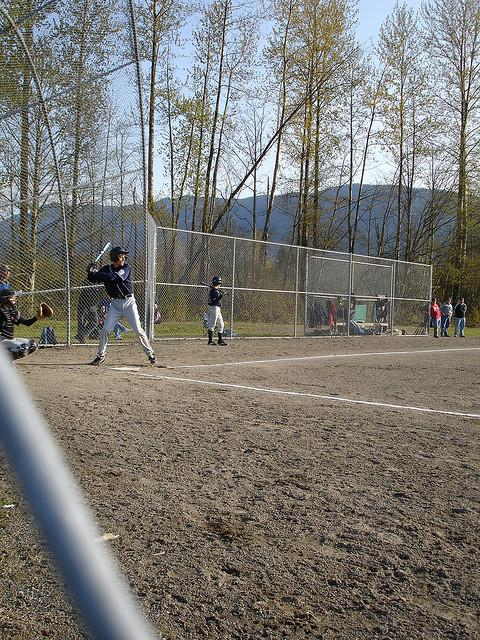What shape is the object used to play this game?

Choices:
A) oval
B) disk
C) oblong
D) round round 